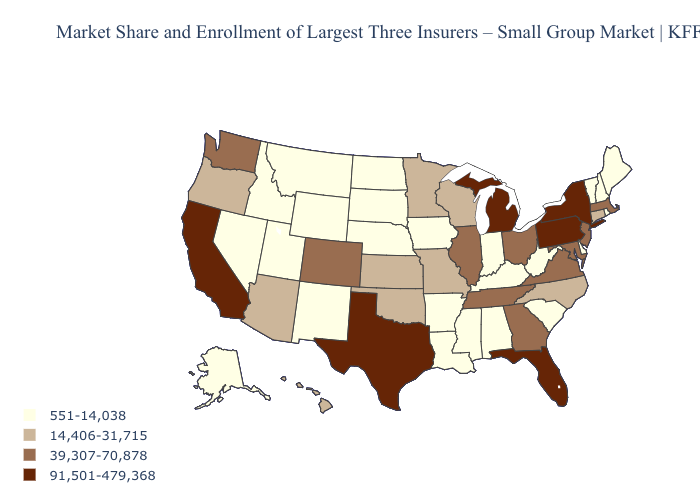Which states hav the highest value in the South?
Short answer required. Florida, Texas. Name the states that have a value in the range 39,307-70,878?
Write a very short answer. Colorado, Georgia, Illinois, Maryland, Massachusetts, New Jersey, Ohio, Tennessee, Virginia, Washington. What is the highest value in states that border Vermont?
Concise answer only. 91,501-479,368. What is the value of Massachusetts?
Answer briefly. 39,307-70,878. What is the value of Idaho?
Give a very brief answer. 551-14,038. Does Mississippi have the same value as North Dakota?
Concise answer only. Yes. What is the value of Oregon?
Give a very brief answer. 14,406-31,715. Which states have the lowest value in the USA?
Quick response, please. Alabama, Alaska, Arkansas, Delaware, Idaho, Indiana, Iowa, Kentucky, Louisiana, Maine, Mississippi, Montana, Nebraska, Nevada, New Hampshire, New Mexico, North Dakota, Rhode Island, South Carolina, South Dakota, Utah, Vermont, West Virginia, Wyoming. Which states have the highest value in the USA?
Give a very brief answer. California, Florida, Michigan, New York, Pennsylvania, Texas. Among the states that border Connecticut , which have the lowest value?
Keep it brief. Rhode Island. Does Arizona have the lowest value in the USA?
Be succinct. No. Name the states that have a value in the range 551-14,038?
Give a very brief answer. Alabama, Alaska, Arkansas, Delaware, Idaho, Indiana, Iowa, Kentucky, Louisiana, Maine, Mississippi, Montana, Nebraska, Nevada, New Hampshire, New Mexico, North Dakota, Rhode Island, South Carolina, South Dakota, Utah, Vermont, West Virginia, Wyoming. Among the states that border Kentucky , does Indiana have the lowest value?
Keep it brief. Yes. Name the states that have a value in the range 39,307-70,878?
Concise answer only. Colorado, Georgia, Illinois, Maryland, Massachusetts, New Jersey, Ohio, Tennessee, Virginia, Washington. Does Alaska have a lower value than Oregon?
Keep it brief. Yes. 